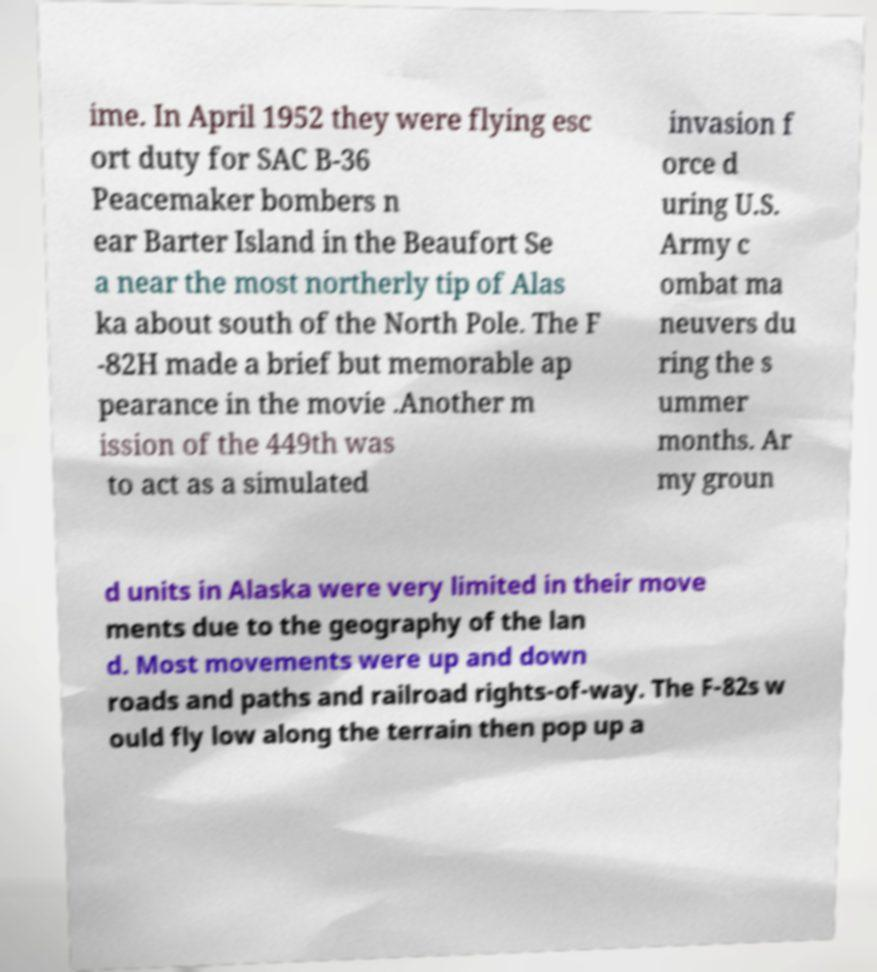Can you accurately transcribe the text from the provided image for me? ime. In April 1952 they were flying esc ort duty for SAC B-36 Peacemaker bombers n ear Barter Island in the Beaufort Se a near the most northerly tip of Alas ka about south of the North Pole. The F -82H made a brief but memorable ap pearance in the movie .Another m ission of the 449th was to act as a simulated invasion f orce d uring U.S. Army c ombat ma neuvers du ring the s ummer months. Ar my groun d units in Alaska were very limited in their move ments due to the geography of the lan d. Most movements were up and down roads and paths and railroad rights-of-way. The F-82s w ould fly low along the terrain then pop up a 